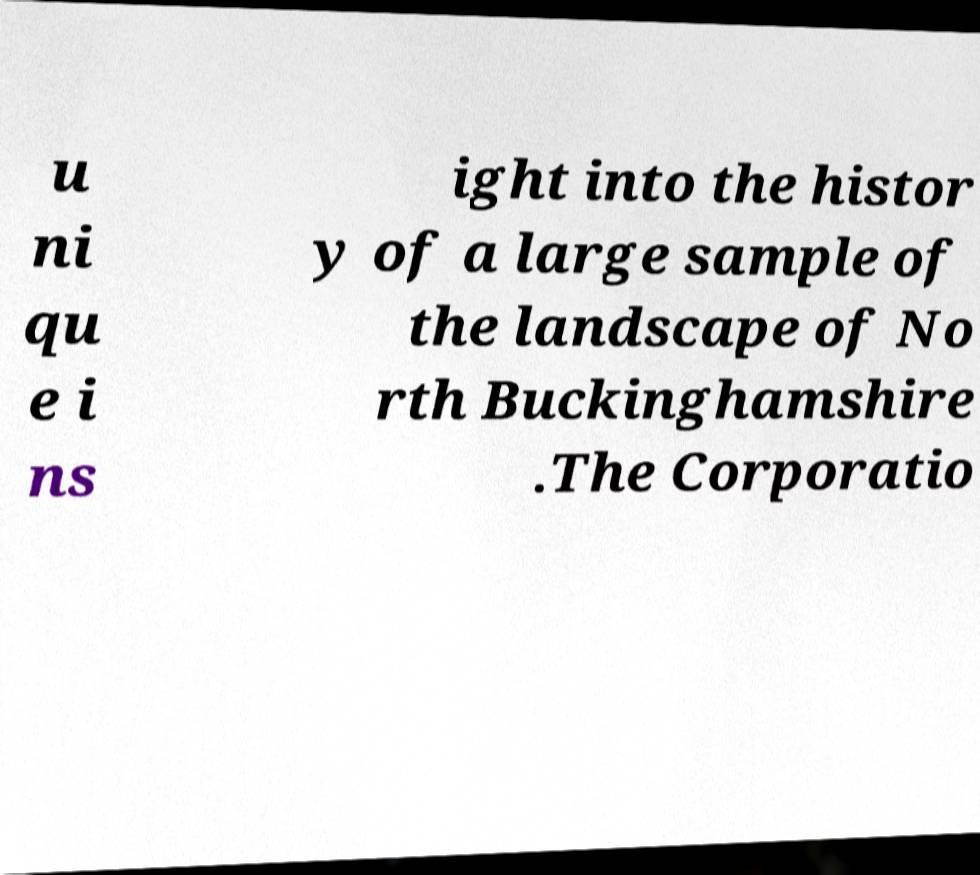Please identify and transcribe the text found in this image. u ni qu e i ns ight into the histor y of a large sample of the landscape of No rth Buckinghamshire .The Corporatio 